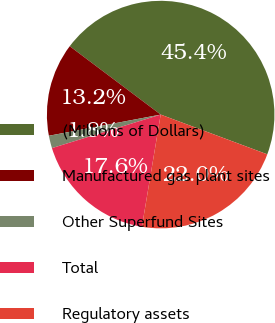Convert chart to OTSL. <chart><loc_0><loc_0><loc_500><loc_500><pie_chart><fcel>(Millions of Dollars)<fcel>Manufactured gas plant sites<fcel>Other Superfund Sites<fcel>Total<fcel>Regulatory assets<nl><fcel>45.42%<fcel>13.24%<fcel>1.78%<fcel>17.6%<fcel>21.96%<nl></chart> 